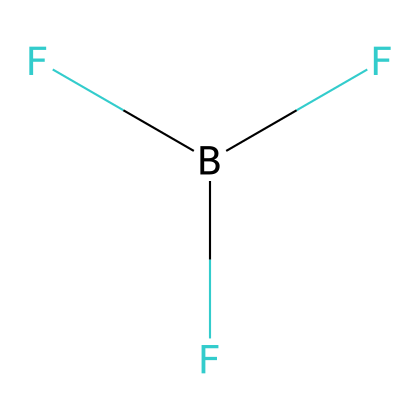How many atoms are in boron trifluoride? The structure B(F)(F)F contains one boron atom (B) and three fluorine atoms (F), so adding these gives a total of four atoms.
Answer: four What is the central atom in boron trifluoride? In the structure B(F)(F)F, the boron atom (B) is the central atom, as it is bonded to the three fluorine atoms.
Answer: boron How many fluorine atoms are present? The structure clearly depicts one boron atom and three fluorine atoms, which shows that there are three fluorine atoms present.
Answer: three What type of molecular geometry does boron trifluoride have? Boron trifluoride has a trigonal planar geometry due to the presence of three bonding pairs around the boron atom with no lone pairs.
Answer: trigonal planar Why is boron trifluoride used in military smoke grenades? Boron trifluoride is known to produce dense smoke when it reacts, making it suitable for obscuring visibility in military operations.
Answer: dense smoke What is the bonding type in boron trifluoride? The boron trifluoride structure reveals that boron forms covalent bonds with each fluorine atom, indicating that the bonding type is covalent.
Answer: covalent 